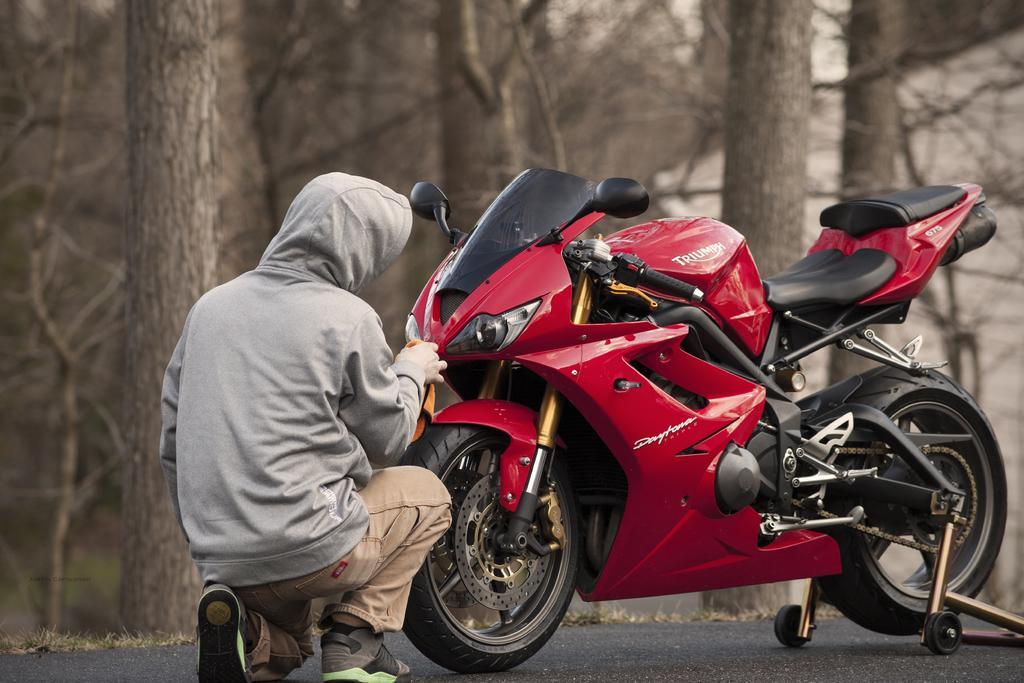Can you describe this image briefly? In this picture we can see a vehicle on the road, one person is sitting and cleaning, side we can see some trees. 